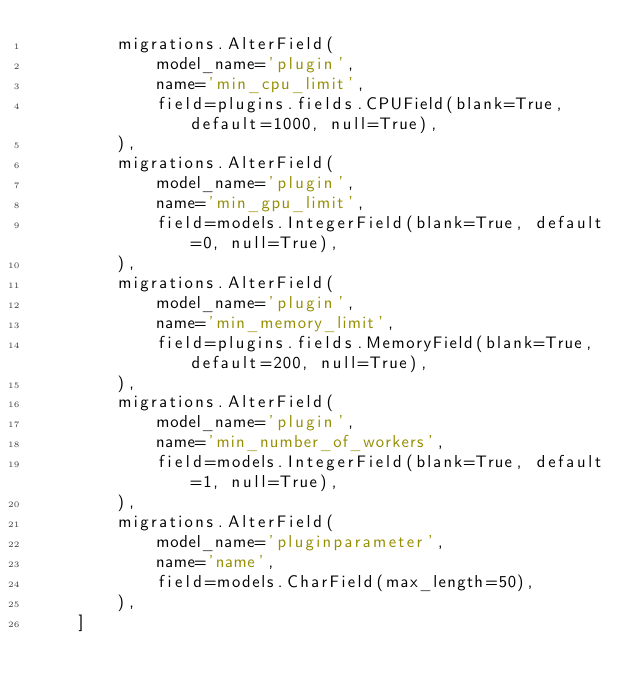<code> <loc_0><loc_0><loc_500><loc_500><_Python_>        migrations.AlterField(
            model_name='plugin',
            name='min_cpu_limit',
            field=plugins.fields.CPUField(blank=True, default=1000, null=True),
        ),
        migrations.AlterField(
            model_name='plugin',
            name='min_gpu_limit',
            field=models.IntegerField(blank=True, default=0, null=True),
        ),
        migrations.AlterField(
            model_name='plugin',
            name='min_memory_limit',
            field=plugins.fields.MemoryField(blank=True, default=200, null=True),
        ),
        migrations.AlterField(
            model_name='plugin',
            name='min_number_of_workers',
            field=models.IntegerField(blank=True, default=1, null=True),
        ),
        migrations.AlterField(
            model_name='pluginparameter',
            name='name',
            field=models.CharField(max_length=50),
        ),
    ]
</code> 